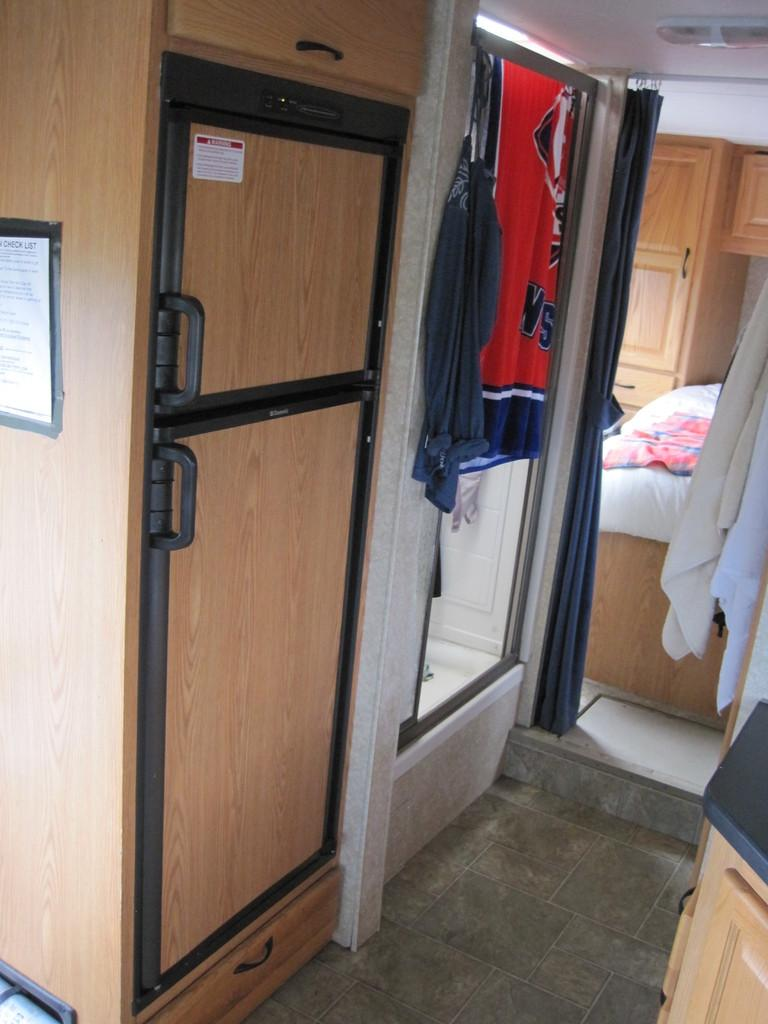What can be seen on some of the objects in the image? There is text on objects in the image. What type of items can be seen in the image? There are clothes visible in the image. What material are some of the objects made of? There are wooden objects in the image. Can you describe the other objects in the image? There are other objects in the image, but their specific details are not mentioned in the provided facts. What type of hate can be seen on the wooden objects in the image? There is no hate present in the image; the provided facts only mention text and wooden objects. What kind of bait is used to catch fish in the image? There is no mention of fish or bait in the image; the provided facts only mention text, clothes, wooden objects, and other objects. 